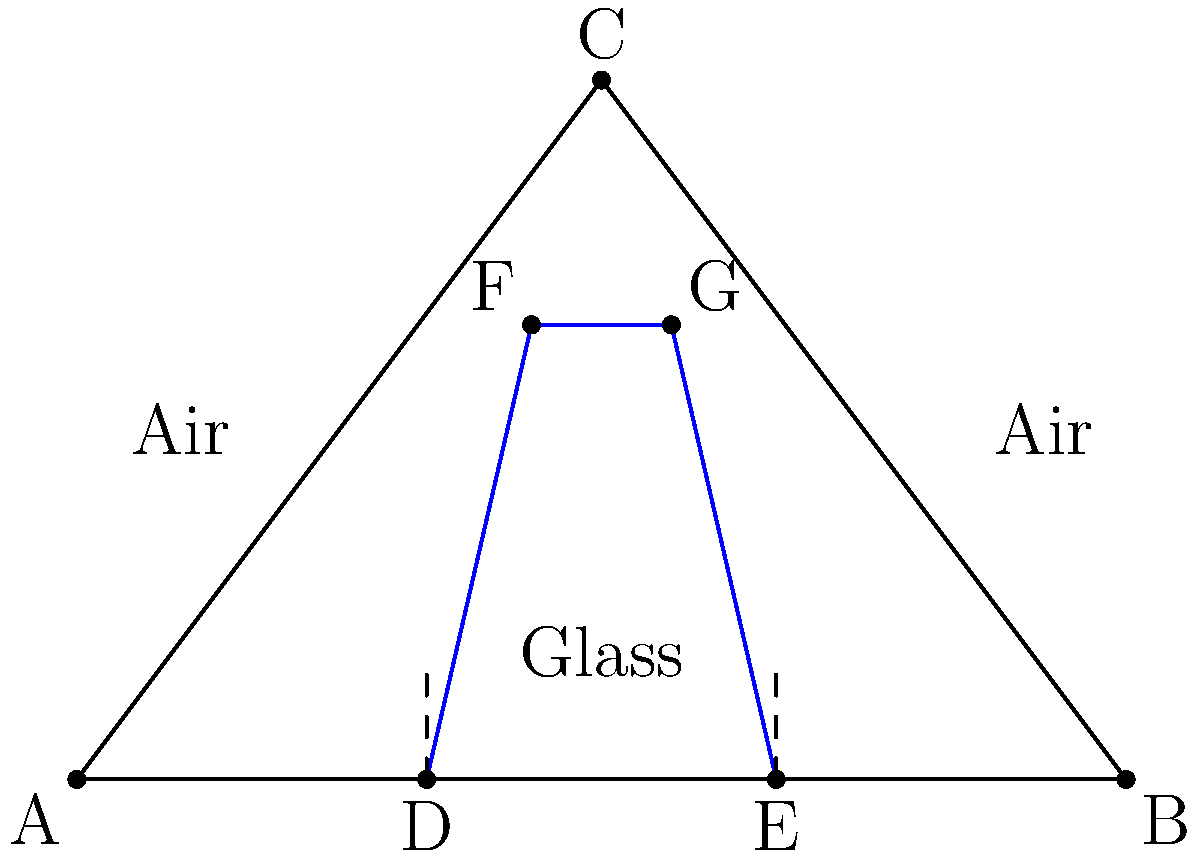In the diagram above, a ray of light travels through a glass prism. The ray enters the prism at point D, refracts at point F, undergoes total internal reflection at point G, and exits the prism at point E. If the angle of incidence at point D is $30°$ and the refractive index of glass is $1.5$, calculate the angle of refraction at point F. Express your answer in degrees, rounded to the nearest tenth. To solve this problem, we'll use Snell's law and the given information:

1) Snell's law states: $n_1 \sin \theta_1 = n_2 \sin \theta_2$

2) Given:
   - Angle of incidence at D = $30°$
   - Refractive index of glass = $1.5$
   - Refractive index of air = $1.0$ (approximately)

3) Let's apply Snell's law at point D:
   $1.0 \sin 30° = 1.5 \sin \theta_2$

4) Solve for $\theta_2$:
   $\sin \theta_2 = \frac{1.0 \sin 30°}{1.5}$
   $\sin \theta_2 = \frac{0.5}{1.5} = \frac{1}{3}$

5) Take the inverse sine (arcsin) of both sides:
   $\theta_2 = \arcsin(\frac{1}{3})$

6) Calculate the result:
   $\theta_2 \approx 19.47°$

7) Round to the nearest tenth:
   $\theta_2 \approx 19.5°$

Therefore, the angle of refraction at point F is approximately $19.5°$.
Answer: 19.5° 